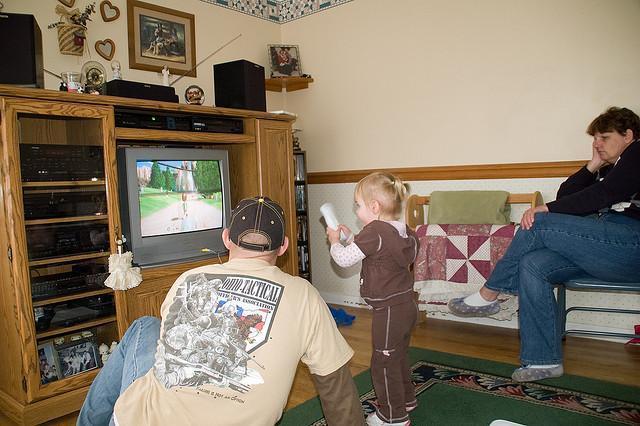How many people are there?
Give a very brief answer. 3. 